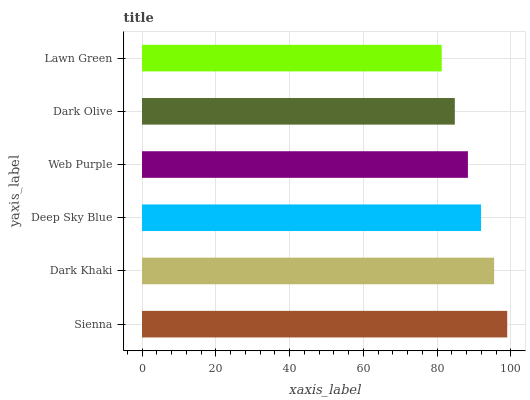Is Lawn Green the minimum?
Answer yes or no. Yes. Is Sienna the maximum?
Answer yes or no. Yes. Is Dark Khaki the minimum?
Answer yes or no. No. Is Dark Khaki the maximum?
Answer yes or no. No. Is Sienna greater than Dark Khaki?
Answer yes or no. Yes. Is Dark Khaki less than Sienna?
Answer yes or no. Yes. Is Dark Khaki greater than Sienna?
Answer yes or no. No. Is Sienna less than Dark Khaki?
Answer yes or no. No. Is Deep Sky Blue the high median?
Answer yes or no. Yes. Is Web Purple the low median?
Answer yes or no. Yes. Is Lawn Green the high median?
Answer yes or no. No. Is Deep Sky Blue the low median?
Answer yes or no. No. 